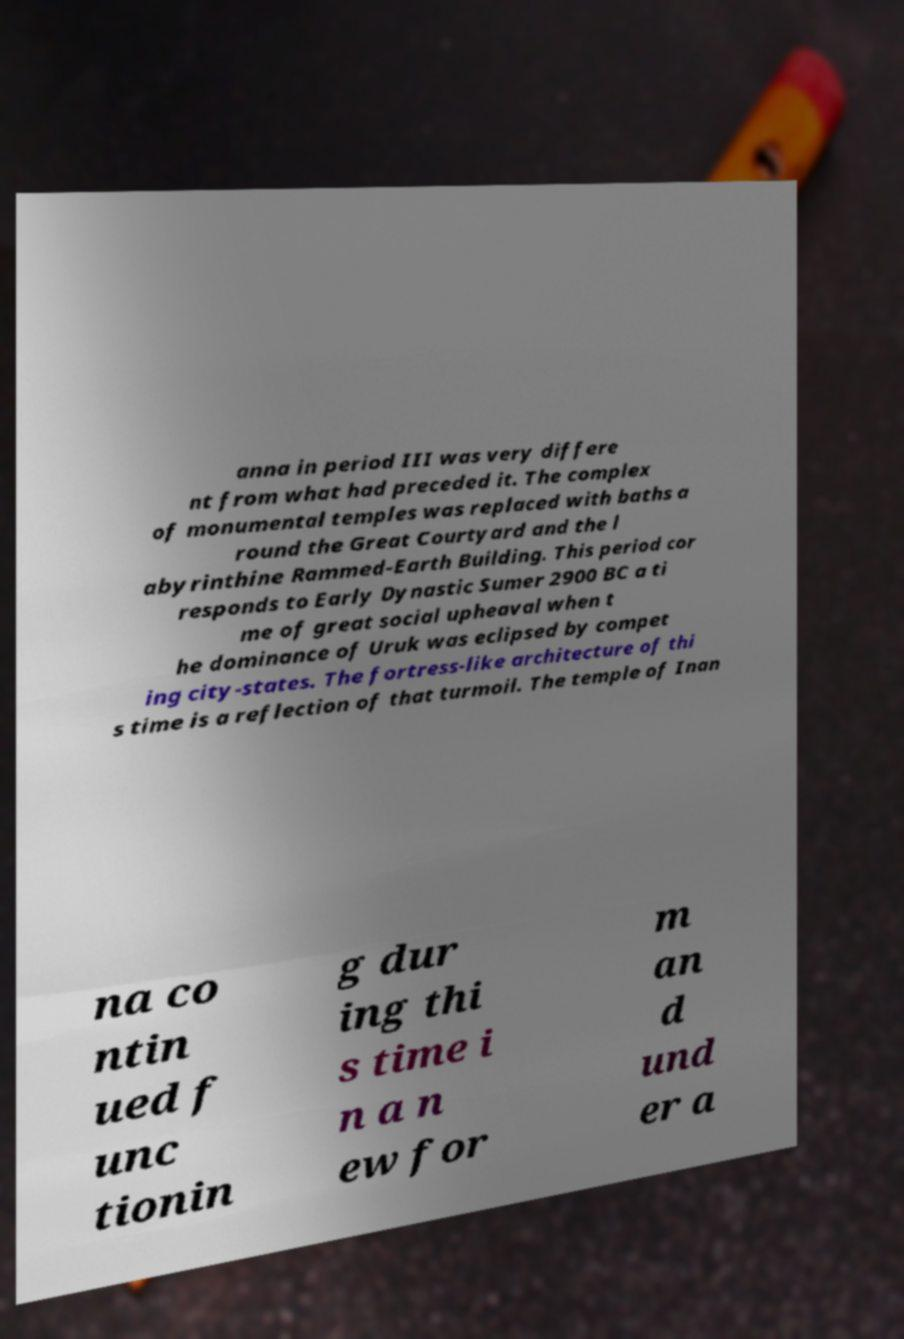Please identify and transcribe the text found in this image. anna in period III was very differe nt from what had preceded it. The complex of monumental temples was replaced with baths a round the Great Courtyard and the l abyrinthine Rammed-Earth Building. This period cor responds to Early Dynastic Sumer 2900 BC a ti me of great social upheaval when t he dominance of Uruk was eclipsed by compet ing city-states. The fortress-like architecture of thi s time is a reflection of that turmoil. The temple of Inan na co ntin ued f unc tionin g dur ing thi s time i n a n ew for m an d und er a 